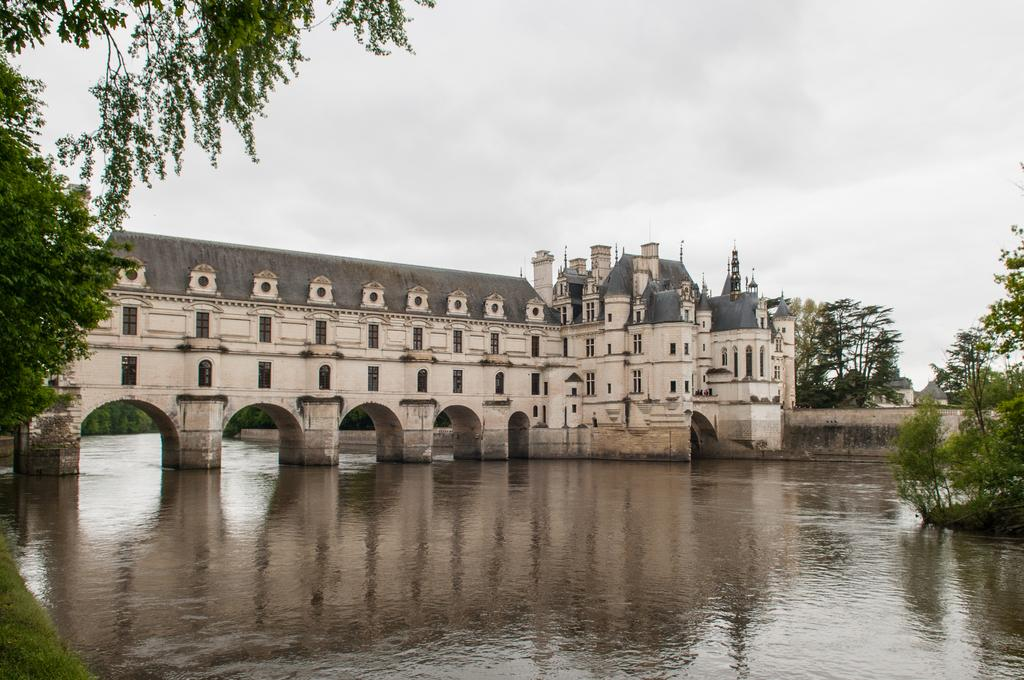What type of structure is in the image? There is a castle in the image. Where is the castle located? The castle is on the water. What can be seen at the bottom of the image? There is water visible at the bottom of the image. What is visible at the top of the image? The sky is visible at the top of the image. What type of vegetation is in the background of the image? There are trees in the background of the image. Can you see any visible veins in the image? There are no visible veins in the image, as it features a castle on the water with a surrounding environment of trees, water, and sky. 